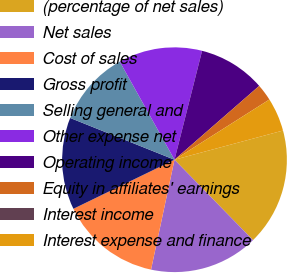<chart> <loc_0><loc_0><loc_500><loc_500><pie_chart><fcel>(percentage of net sales)<fcel>Net sales<fcel>Cost of sales<fcel>Gross profit<fcel>Selling general and<fcel>Other expense net<fcel>Operating income<fcel>Equity in affiliates' earnings<fcel>Interest income<fcel>Interest expense and finance<nl><fcel>16.87%<fcel>15.66%<fcel>14.46%<fcel>13.25%<fcel>10.84%<fcel>12.05%<fcel>9.64%<fcel>2.41%<fcel>0.0%<fcel>4.82%<nl></chart> 